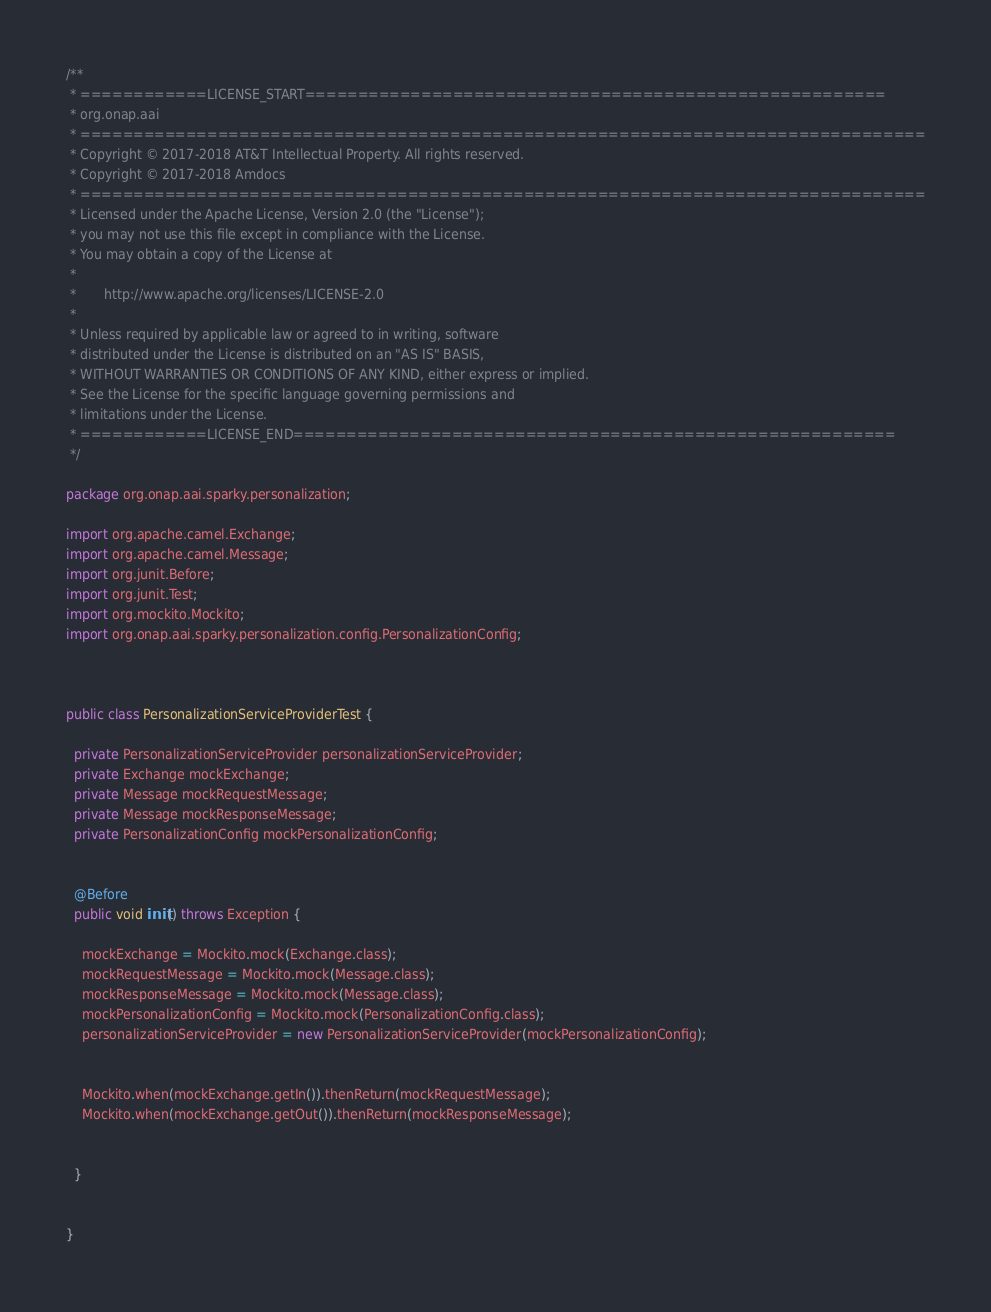<code> <loc_0><loc_0><loc_500><loc_500><_Java_>/**
 * ============LICENSE_START=======================================================
 * org.onap.aai
 * ================================================================================
 * Copyright © 2017-2018 AT&T Intellectual Property. All rights reserved.
 * Copyright © 2017-2018 Amdocs
 * ================================================================================
 * Licensed under the Apache License, Version 2.0 (the "License");
 * you may not use this file except in compliance with the License.
 * You may obtain a copy of the License at
 *
 *       http://www.apache.org/licenses/LICENSE-2.0
 *
 * Unless required by applicable law or agreed to in writing, software
 * distributed under the License is distributed on an "AS IS" BASIS,
 * WITHOUT WARRANTIES OR CONDITIONS OF ANY KIND, either express or implied.
 * See the License for the specific language governing permissions and
 * limitations under the License.
 * ============LICENSE_END=========================================================
 */

package org.onap.aai.sparky.personalization;

import org.apache.camel.Exchange;
import org.apache.camel.Message;
import org.junit.Before;
import org.junit.Test;
import org.mockito.Mockito;
import org.onap.aai.sparky.personalization.config.PersonalizationConfig;



public class PersonalizationServiceProviderTest {

  private PersonalizationServiceProvider personalizationServiceProvider;
  private Exchange mockExchange;
  private Message mockRequestMessage;
  private Message mockResponseMessage;
  private PersonalizationConfig mockPersonalizationConfig;


  @Before
  public void init() throws Exception {

    mockExchange = Mockito.mock(Exchange.class);
    mockRequestMessage = Mockito.mock(Message.class);
    mockResponseMessage = Mockito.mock(Message.class);
    mockPersonalizationConfig = Mockito.mock(PersonalizationConfig.class);
    personalizationServiceProvider = new PersonalizationServiceProvider(mockPersonalizationConfig);


    Mockito.when(mockExchange.getIn()).thenReturn(mockRequestMessage);
    Mockito.when(mockExchange.getOut()).thenReturn(mockResponseMessage);

   
  }
  

}
</code> 